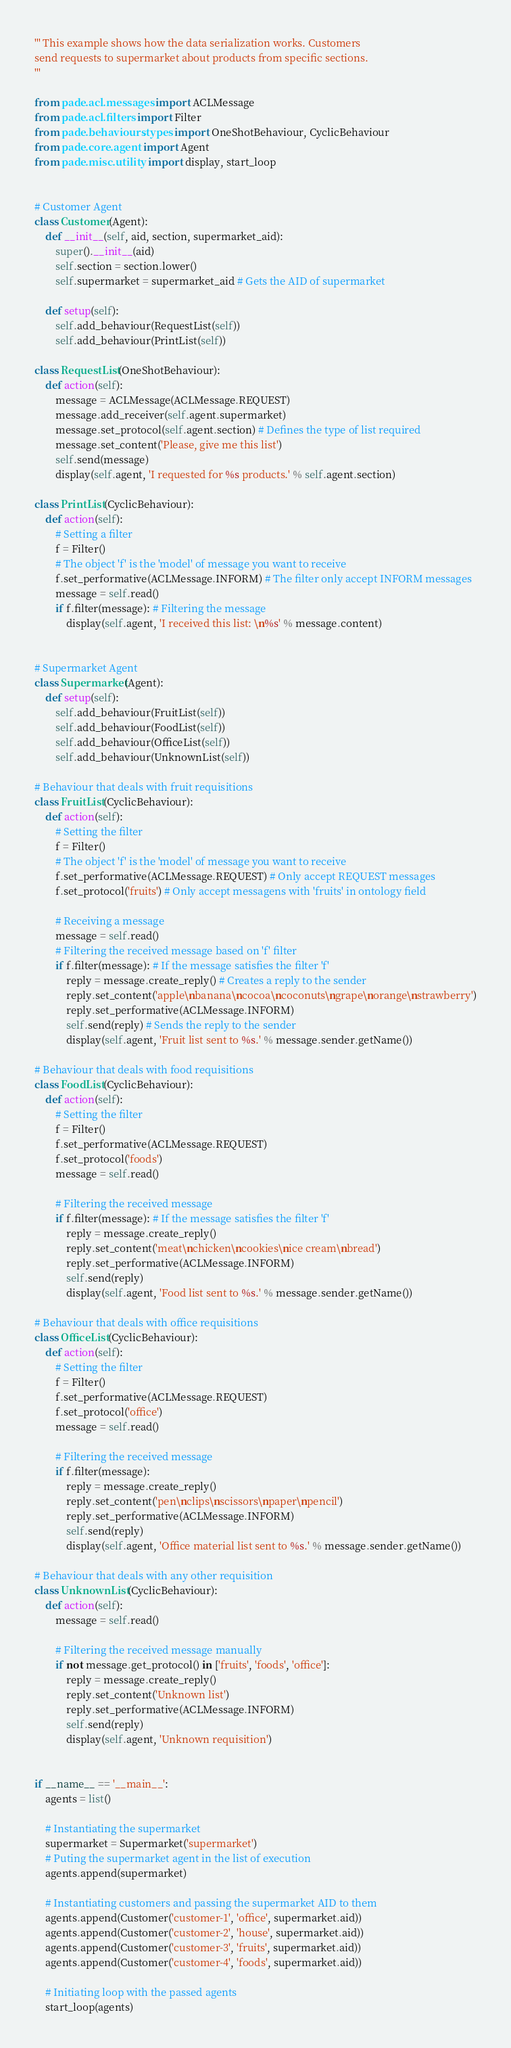<code> <loc_0><loc_0><loc_500><loc_500><_Python_>''' This example shows how the data serialization works. Customers
send requests to supermarket about products from specific sections.
'''

from pade.acl.messages import ACLMessage
from pade.acl.filters import Filter
from pade.behaviours.types import OneShotBehaviour, CyclicBehaviour
from pade.core.agent import Agent
from pade.misc.utility import display, start_loop


# Customer Agent
class Customer(Agent):
	def __init__(self, aid, section, supermarket_aid):
		super().__init__(aid)
		self.section = section.lower()
		self.supermarket = supermarket_aid # Gets the AID of supermarket

	def setup(self):
		self.add_behaviour(RequestList(self))
		self.add_behaviour(PrintList(self))

class RequestList(OneShotBehaviour):
	def action(self):
		message = ACLMessage(ACLMessage.REQUEST)
		message.add_receiver(self.agent.supermarket)
		message.set_protocol(self.agent.section) # Defines the type of list required
		message.set_content('Please, give me this list')
		self.send(message)
		display(self.agent, 'I requested for %s products.' % self.agent.section)

class PrintList(CyclicBehaviour):
	def action(self):
		# Setting a filter
		f = Filter()
		# The object 'f' is the 'model' of message you want to receive
		f.set_performative(ACLMessage.INFORM) # The filter only accept INFORM messages
		message = self.read()
		if f.filter(message): # Filtering the message
			display(self.agent, 'I received this list: \n%s' % message.content)


# Supermarket Agent
class Supermarket(Agent):
	def setup(self):
		self.add_behaviour(FruitList(self))
		self.add_behaviour(FoodList(self))
		self.add_behaviour(OfficeList(self))
		self.add_behaviour(UnknownList(self))

# Behaviour that deals with fruit requisitions
class FruitList(CyclicBehaviour):
	def action(self):
		# Setting the filter
		f = Filter()
		# The object 'f' is the 'model' of message you want to receive
		f.set_performative(ACLMessage.REQUEST) # Only accept REQUEST messages
		f.set_protocol('fruits') # Only accept messagens with 'fruits' in ontology field

		# Receiving a message
		message = self.read()
		# Filtering the received message based on 'f' filter
		if f.filter(message): # If the message satisfies the filter 'f'
			reply = message.create_reply() # Creates a reply to the sender
			reply.set_content('apple\nbanana\ncocoa\ncoconuts\ngrape\norange\nstrawberry')
			reply.set_performative(ACLMessage.INFORM)
			self.send(reply) # Sends the reply to the sender
			display(self.agent, 'Fruit list sent to %s.' % message.sender.getName())

# Behaviour that deals with food requisitions
class FoodList(CyclicBehaviour):
	def action(self):
		# Setting the filter
		f = Filter()
		f.set_performative(ACLMessage.REQUEST)
		f.set_protocol('foods')
		message = self.read()

		# Filtering the received message
		if f.filter(message): # If the message satisfies the filter 'f'
			reply = message.create_reply()
			reply.set_content('meat\nchicken\ncookies\nice cream\nbread')
			reply.set_performative(ACLMessage.INFORM)
			self.send(reply)
			display(self.agent, 'Food list sent to %s.' % message.sender.getName())

# Behaviour that deals with office requisitions
class OfficeList(CyclicBehaviour):
	def action(self):
		# Setting the filter
		f = Filter()
		f.set_performative(ACLMessage.REQUEST)
		f.set_protocol('office')
		message = self.read()

		# Filtering the received message
		if f.filter(message):
			reply = message.create_reply()
			reply.set_content('pen\nclips\nscissors\npaper\npencil')
			reply.set_performative(ACLMessage.INFORM)
			self.send(reply)
			display(self.agent, 'Office material list sent to %s.' % message.sender.getName())

# Behaviour that deals with any other requisition
class UnknownList(CyclicBehaviour):
	def action(self):
		message = self.read()

		# Filtering the received message manually
		if not message.get_protocol() in ['fruits', 'foods', 'office']:
			reply = message.create_reply()
			reply.set_content('Unknown list')
			reply.set_performative(ACLMessage.INFORM)
			self.send(reply)
			display(self.agent, 'Unknown requisition')


if __name__ == '__main__':
	agents = list()

	# Instantiating the supermarket
	supermarket = Supermarket('supermarket')
	# Puting the supermarket agent in the list of execution
	agents.append(supermarket)

	# Instantiating customers and passing the supermarket AID to them
	agents.append(Customer('customer-1', 'office', supermarket.aid))
	agents.append(Customer('customer-2', 'house', supermarket.aid))
	agents.append(Customer('customer-3', 'fruits', supermarket.aid))
	agents.append(Customer('customer-4', 'foods', supermarket.aid))

	# Initiating loop with the passed agents
	start_loop(agents)</code> 